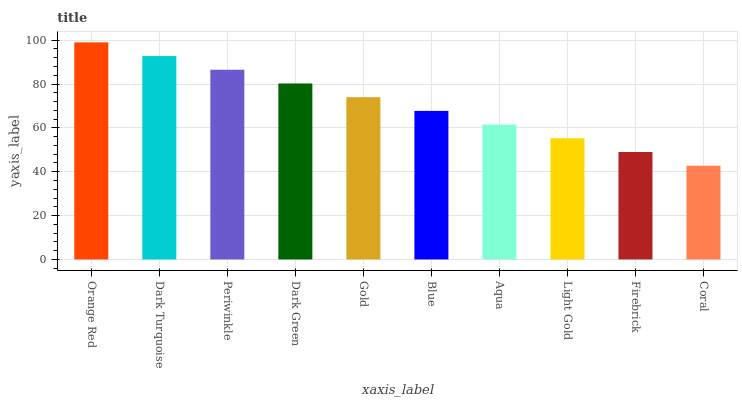Is Coral the minimum?
Answer yes or no. Yes. Is Orange Red the maximum?
Answer yes or no. Yes. Is Dark Turquoise the minimum?
Answer yes or no. No. Is Dark Turquoise the maximum?
Answer yes or no. No. Is Orange Red greater than Dark Turquoise?
Answer yes or no. Yes. Is Dark Turquoise less than Orange Red?
Answer yes or no. Yes. Is Dark Turquoise greater than Orange Red?
Answer yes or no. No. Is Orange Red less than Dark Turquoise?
Answer yes or no. No. Is Gold the high median?
Answer yes or no. Yes. Is Blue the low median?
Answer yes or no. Yes. Is Coral the high median?
Answer yes or no. No. Is Dark Green the low median?
Answer yes or no. No. 